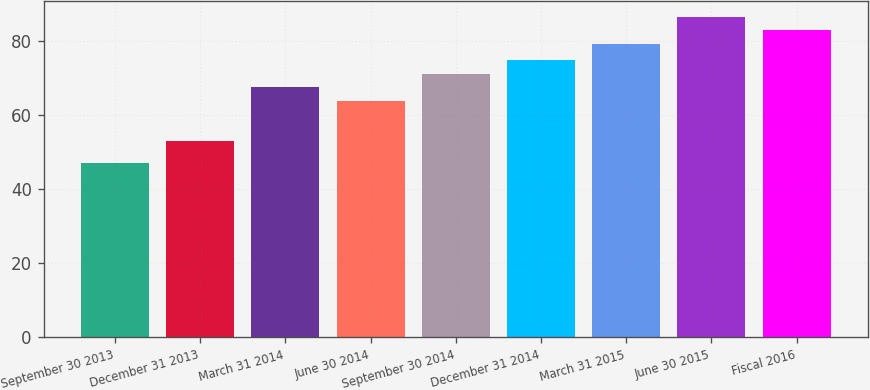<chart> <loc_0><loc_0><loc_500><loc_500><bar_chart><fcel>September 30 2013<fcel>December 31 2013<fcel>March 31 2014<fcel>June 30 2014<fcel>September 30 2014<fcel>December 31 2014<fcel>March 31 2015<fcel>June 30 2015<fcel>Fiscal 2016<nl><fcel>47.02<fcel>52.95<fcel>67.46<fcel>63.8<fcel>71.12<fcel>74.78<fcel>79.19<fcel>86.51<fcel>82.85<nl></chart> 